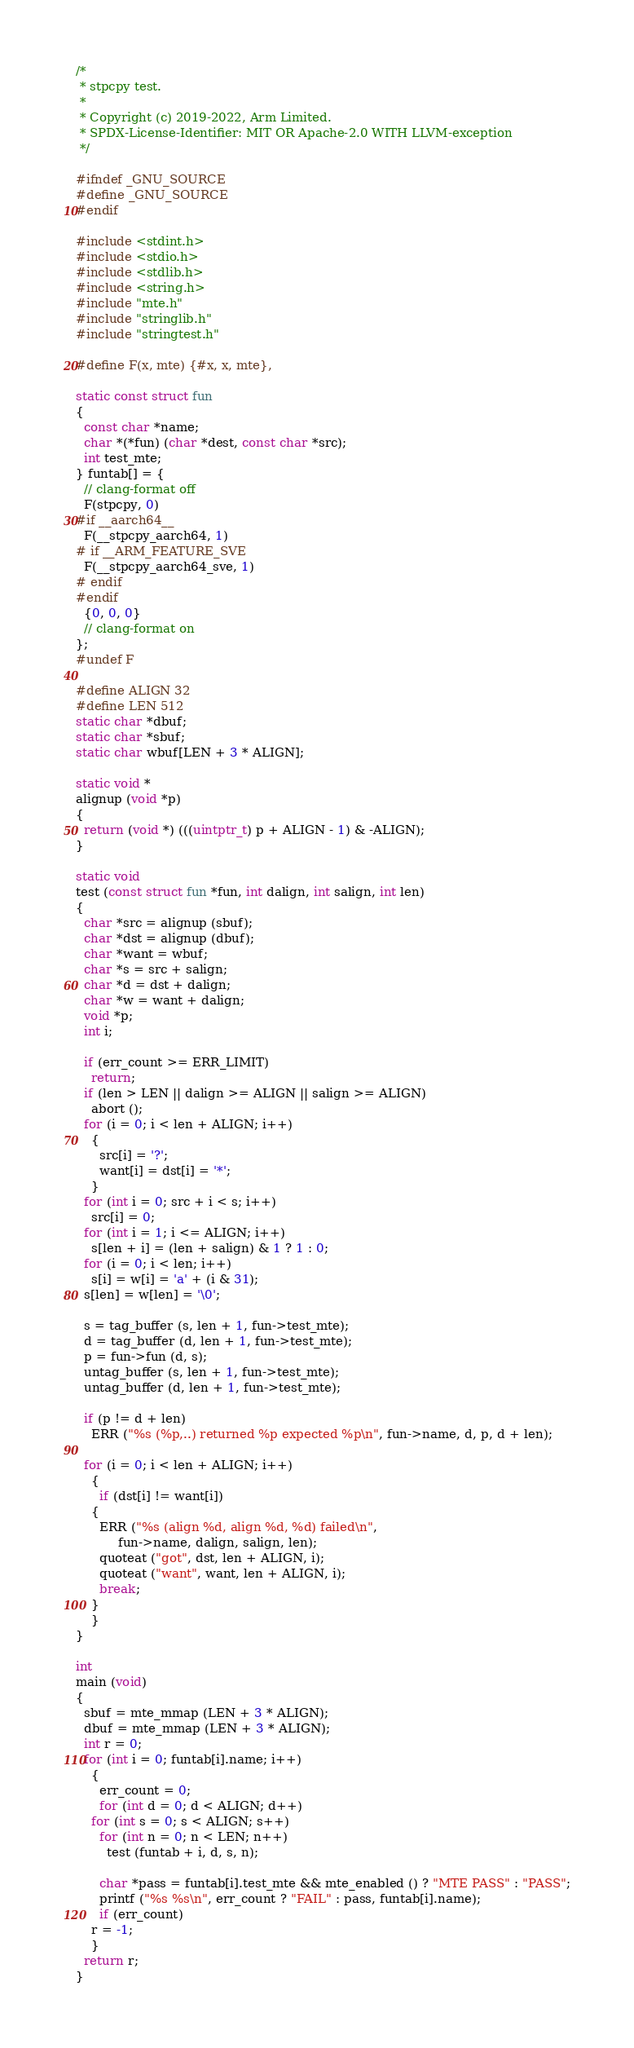<code> <loc_0><loc_0><loc_500><loc_500><_C_>/*
 * stpcpy test.
 *
 * Copyright (c) 2019-2022, Arm Limited.
 * SPDX-License-Identifier: MIT OR Apache-2.0 WITH LLVM-exception
 */

#ifndef _GNU_SOURCE
#define _GNU_SOURCE
#endif

#include <stdint.h>
#include <stdio.h>
#include <stdlib.h>
#include <string.h>
#include "mte.h"
#include "stringlib.h"
#include "stringtest.h"

#define F(x, mte) {#x, x, mte},

static const struct fun
{
  const char *name;
  char *(*fun) (char *dest, const char *src);
  int test_mte;
} funtab[] = {
  // clang-format off
  F(stpcpy, 0)
#if __aarch64__
  F(__stpcpy_aarch64, 1)
# if __ARM_FEATURE_SVE
  F(__stpcpy_aarch64_sve, 1)
# endif
#endif
  {0, 0, 0}
  // clang-format on
};
#undef F

#define ALIGN 32
#define LEN 512
static char *dbuf;
static char *sbuf;
static char wbuf[LEN + 3 * ALIGN];

static void *
alignup (void *p)
{
  return (void *) (((uintptr_t) p + ALIGN - 1) & -ALIGN);
}

static void
test (const struct fun *fun, int dalign, int salign, int len)
{
  char *src = alignup (sbuf);
  char *dst = alignup (dbuf);
  char *want = wbuf;
  char *s = src + salign;
  char *d = dst + dalign;
  char *w = want + dalign;
  void *p;
  int i;

  if (err_count >= ERR_LIMIT)
    return;
  if (len > LEN || dalign >= ALIGN || salign >= ALIGN)
    abort ();
  for (i = 0; i < len + ALIGN; i++)
    {
      src[i] = '?';
      want[i] = dst[i] = '*';
    }
  for (int i = 0; src + i < s; i++)
    src[i] = 0;
  for (int i = 1; i <= ALIGN; i++)
    s[len + i] = (len + salign) & 1 ? 1 : 0;
  for (i = 0; i < len; i++)
    s[i] = w[i] = 'a' + (i & 31);
  s[len] = w[len] = '\0';

  s = tag_buffer (s, len + 1, fun->test_mte);
  d = tag_buffer (d, len + 1, fun->test_mte);
  p = fun->fun (d, s);
  untag_buffer (s, len + 1, fun->test_mte);
  untag_buffer (d, len + 1, fun->test_mte);

  if (p != d + len)
    ERR ("%s (%p,..) returned %p expected %p\n", fun->name, d, p, d + len);

  for (i = 0; i < len + ALIGN; i++)
    {
      if (dst[i] != want[i])
	{
	  ERR ("%s (align %d, align %d, %d) failed\n",
	       fun->name, dalign, salign, len);
	  quoteat ("got", dst, len + ALIGN, i);
	  quoteat ("want", want, len + ALIGN, i);
	  break;
	}
    }
}

int
main (void)
{
  sbuf = mte_mmap (LEN + 3 * ALIGN);
  dbuf = mte_mmap (LEN + 3 * ALIGN);
  int r = 0;
  for (int i = 0; funtab[i].name; i++)
    {
      err_count = 0;
      for (int d = 0; d < ALIGN; d++)
	for (int s = 0; s < ALIGN; s++)
	  for (int n = 0; n < LEN; n++)
	    test (funtab + i, d, s, n);

      char *pass = funtab[i].test_mte && mte_enabled () ? "MTE PASS" : "PASS";
      printf ("%s %s\n", err_count ? "FAIL" : pass, funtab[i].name);
      if (err_count)
	r = -1;
    }
  return r;
}
</code> 